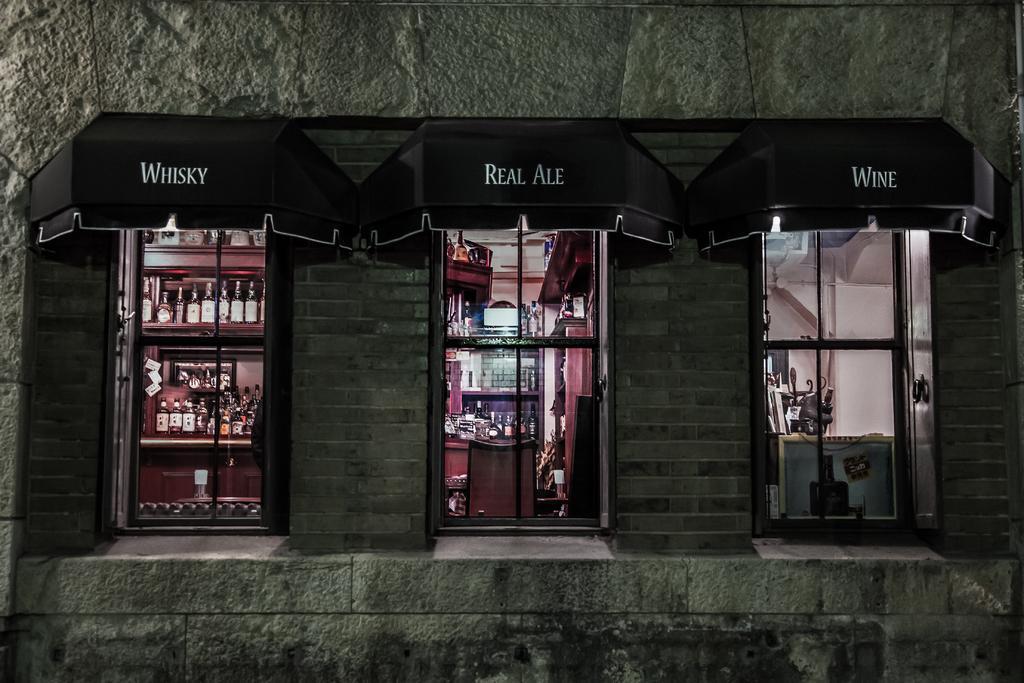In one or two sentences, can you explain what this image depicts? In this image we can see one building wall with three windows, some text on the black roof, some bottles in the racks and some objects in the building. 